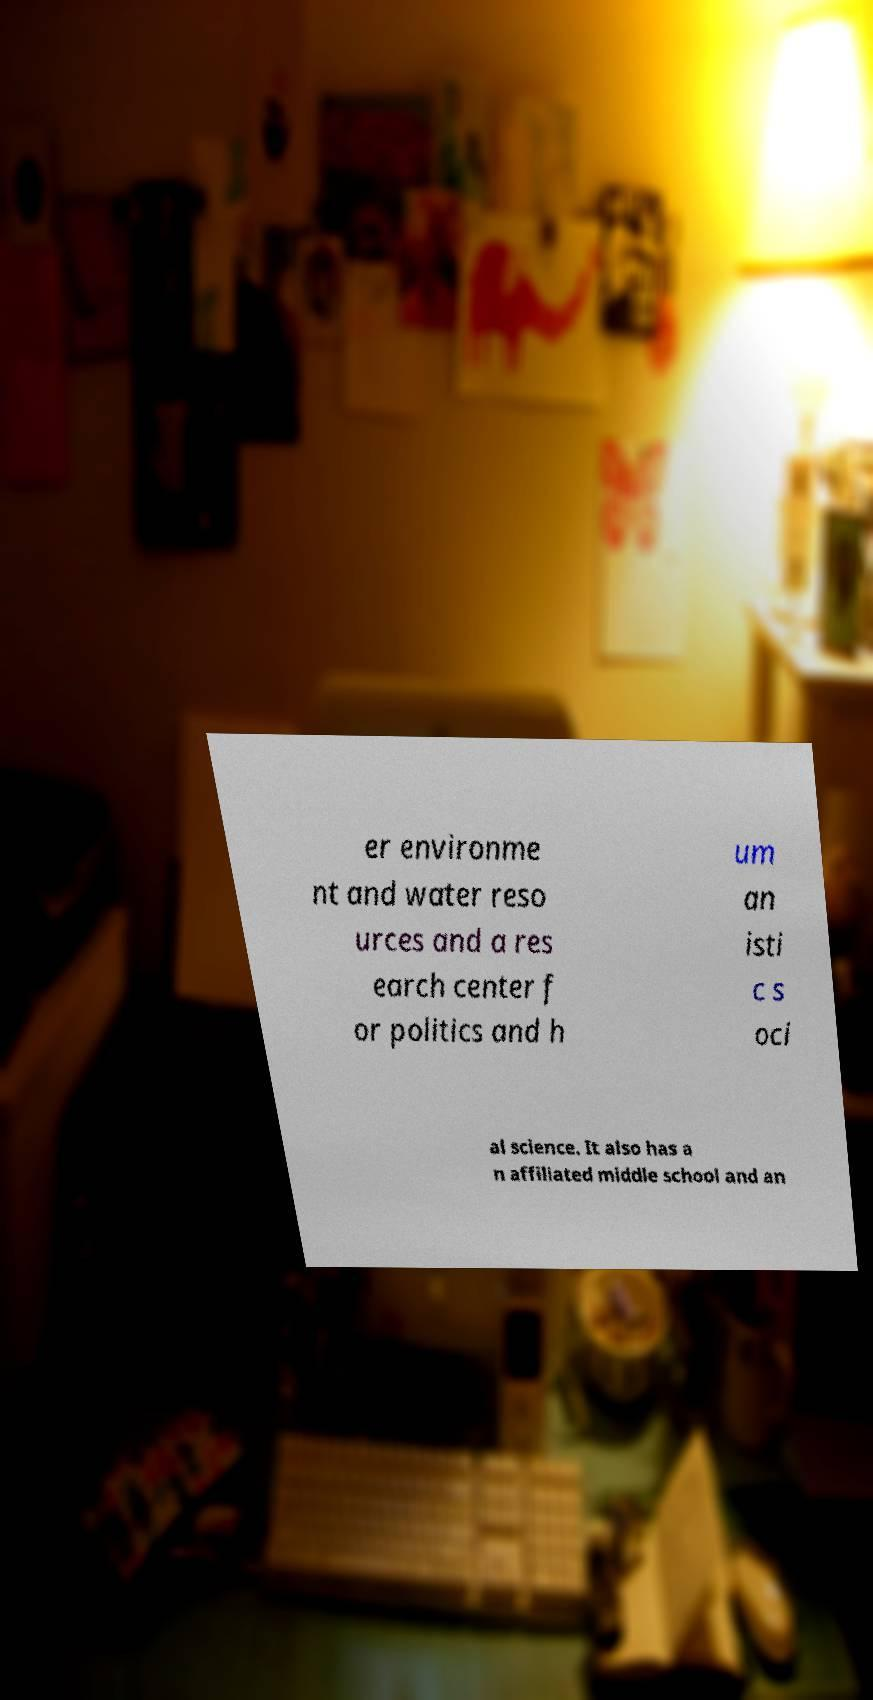I need the written content from this picture converted into text. Can you do that? er environme nt and water reso urces and a res earch center f or politics and h um an isti c s oci al science. It also has a n affiliated middle school and an 